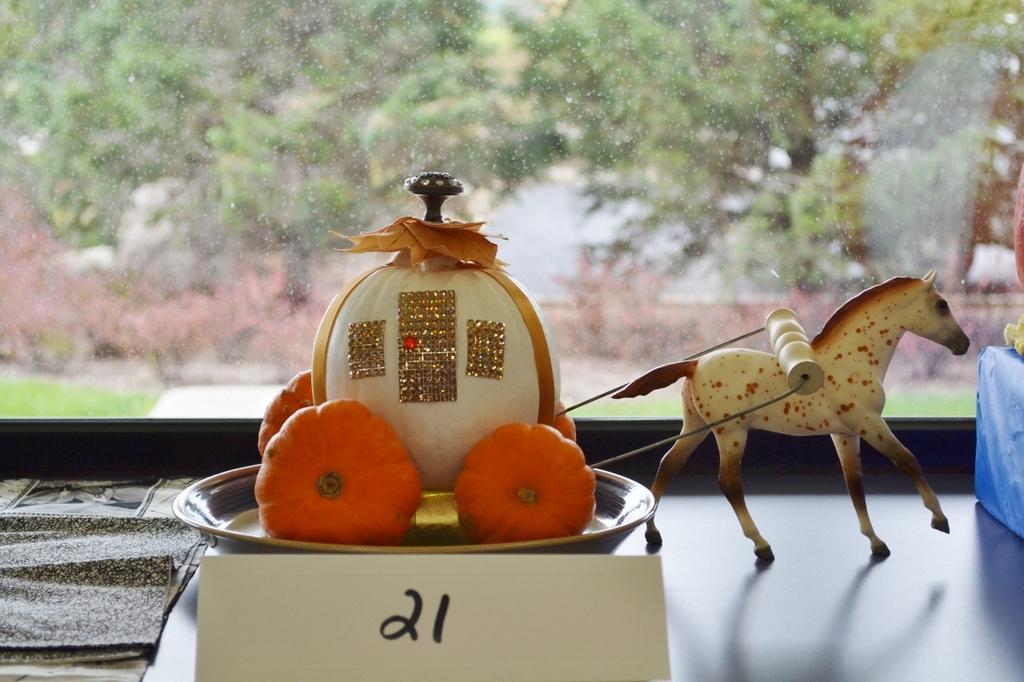Could you give a brief overview of what you see in this image? On the left side, there is a sheet on a surface on which there is a plate having some toy fruits and there is a number plate. On the right side, there are toy horse and a blue color box. In the background, there is a glass window. Through this window, we can see there are trees, grass and a wall. 